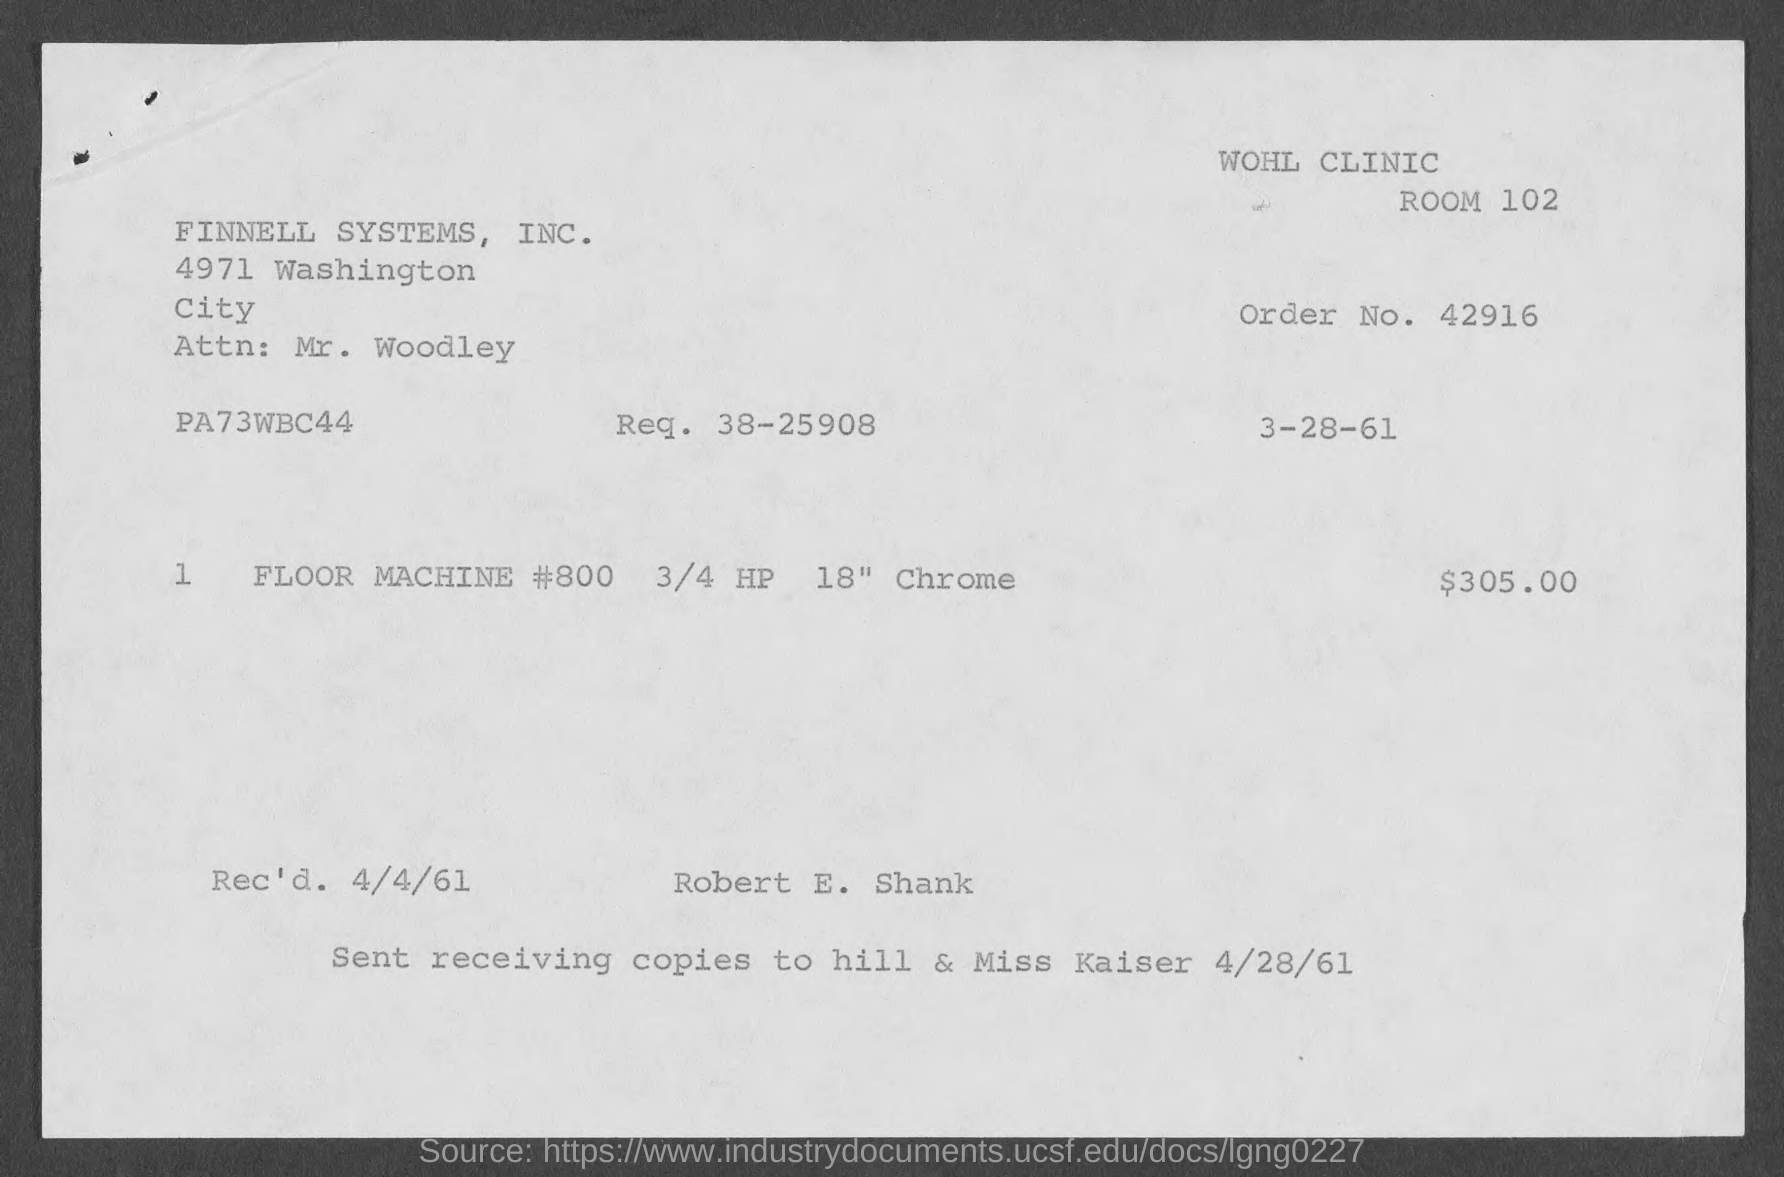What is the order no.?
Make the answer very short. 42916. What is the Req. ?
Provide a succinct answer. 38-25908. When was the document received?
Offer a very short reply. 4/4/61. 